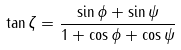<formula> <loc_0><loc_0><loc_500><loc_500>\tan \zeta = \frac { \sin \phi + \sin \psi } { 1 + \cos \phi + \cos \psi }</formula> 